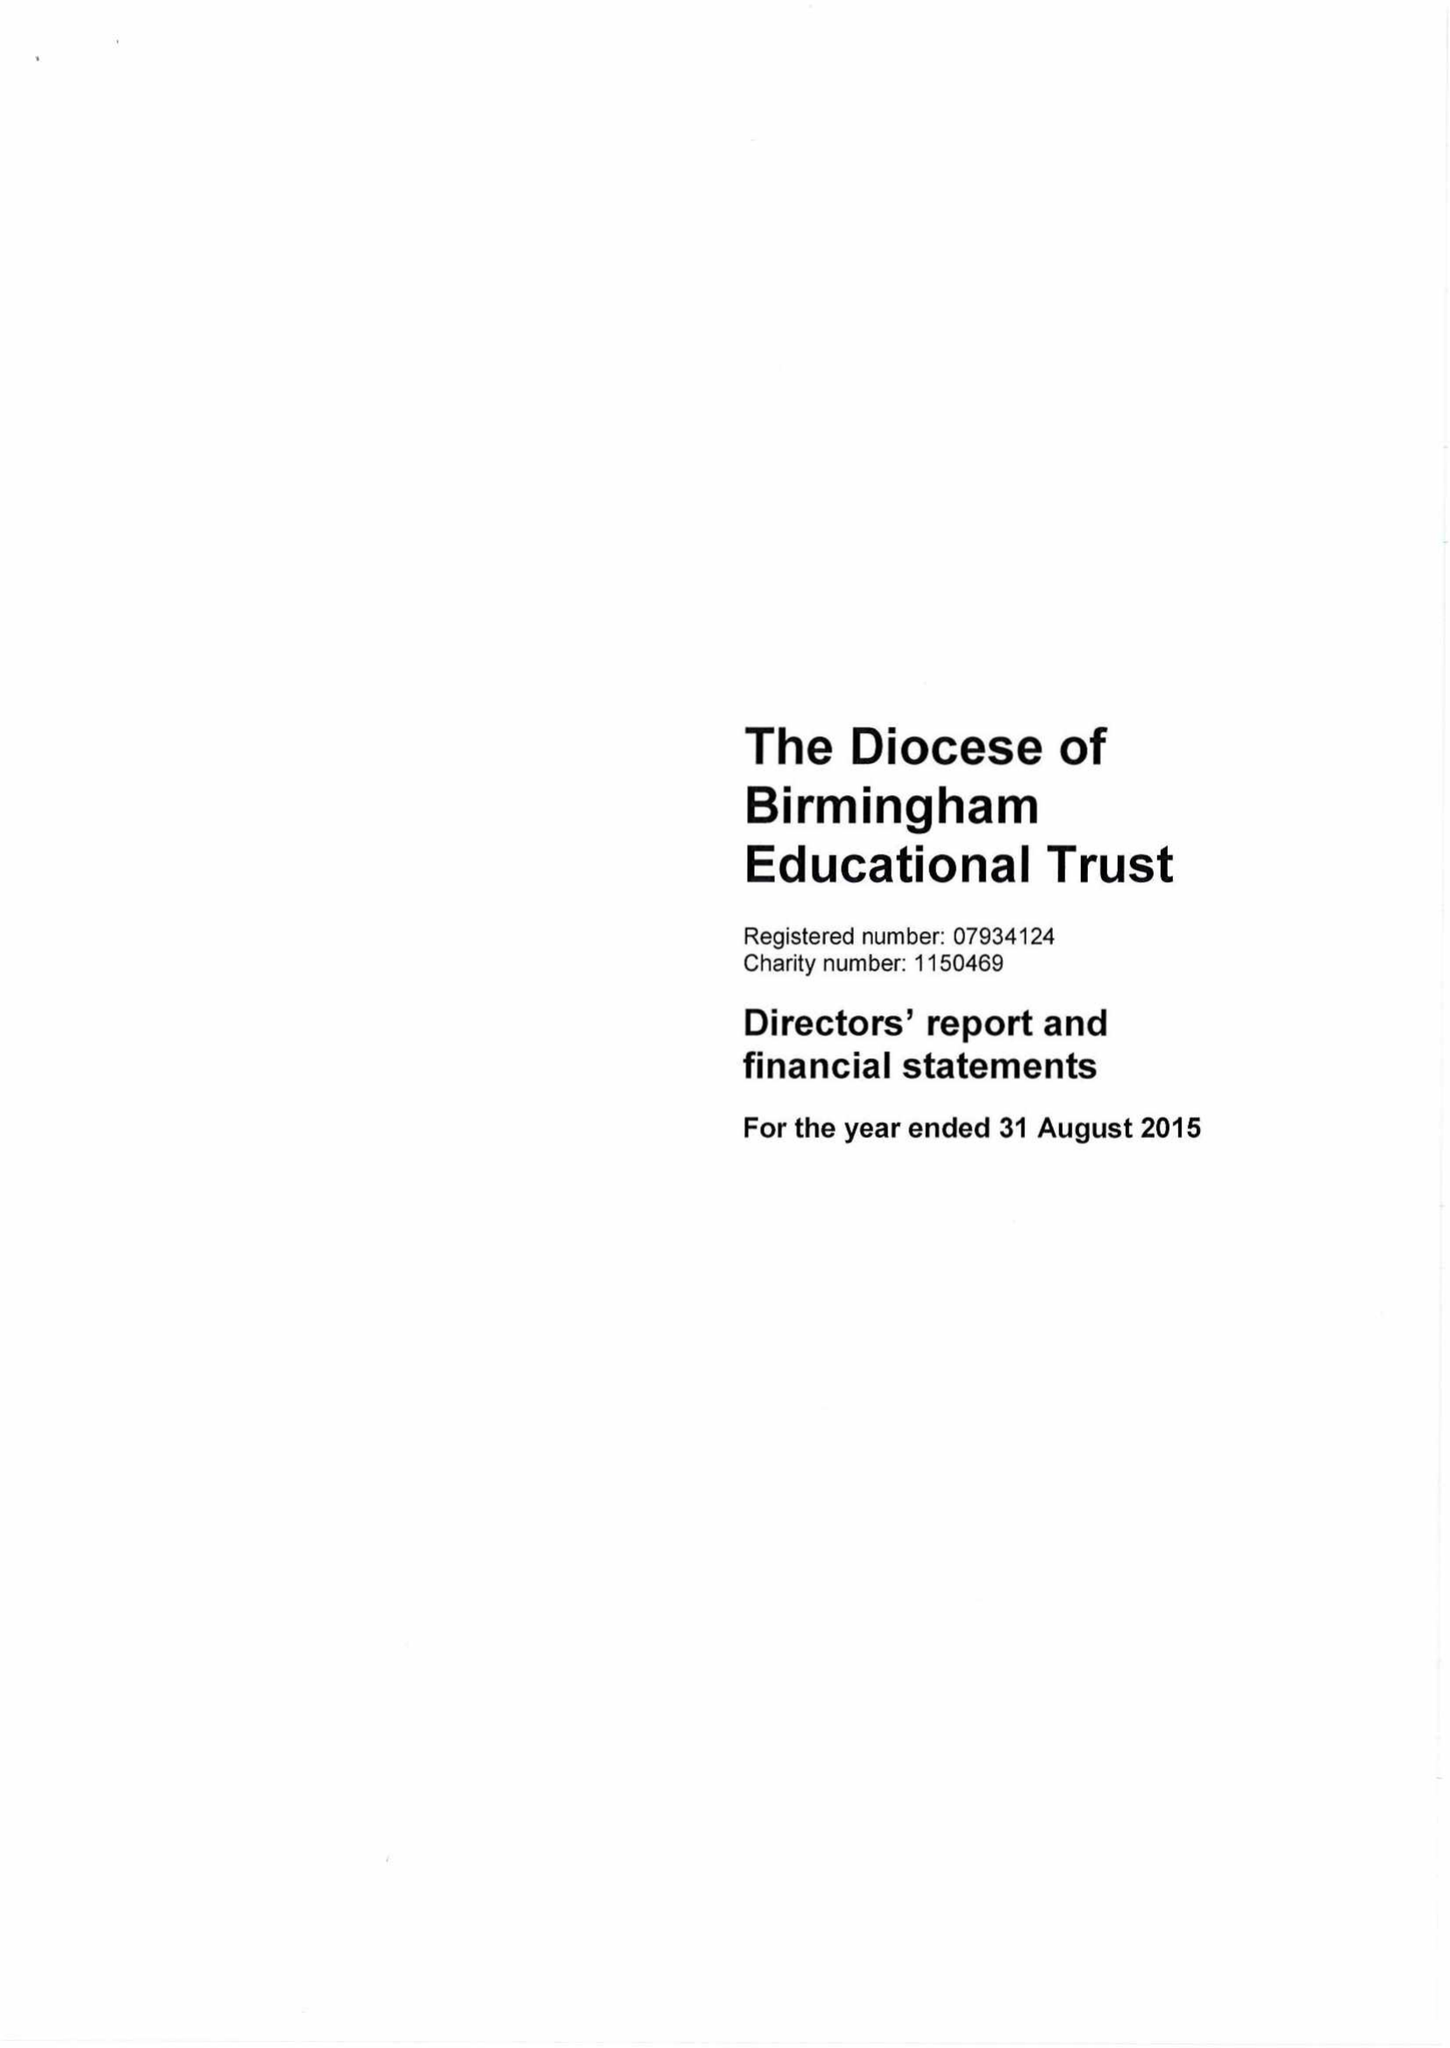What is the value for the income_annually_in_british_pounds?
Answer the question using a single word or phrase. 227200.00 